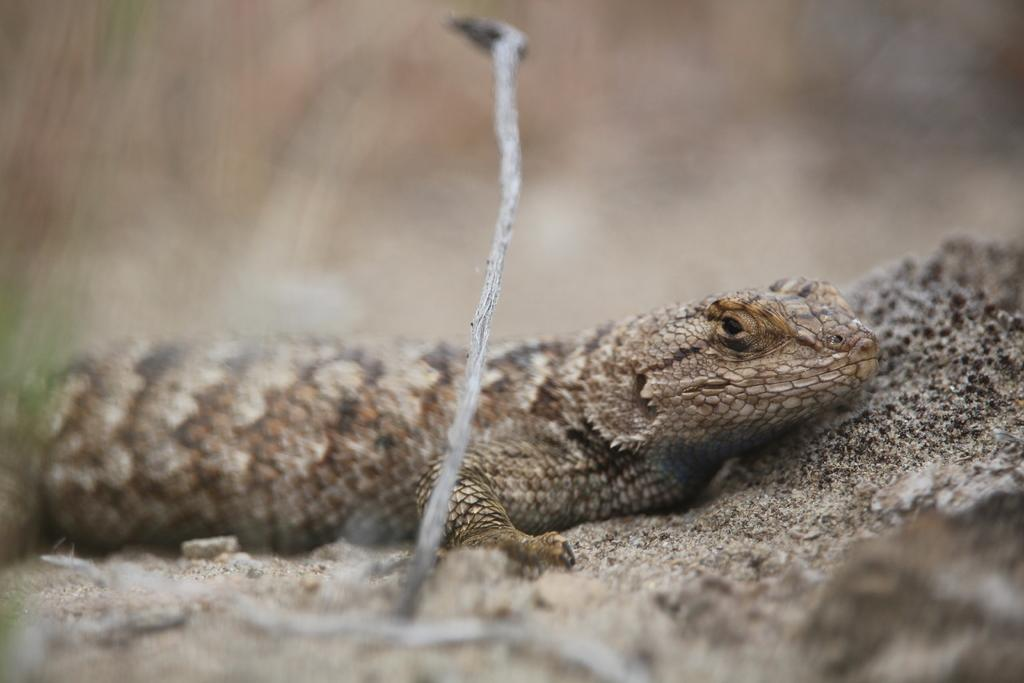What type of animal is in the image? There is a reptile in the image. What can be seen in the foreground of the image? There is a twig in the foreground of the image. How would you describe the background of the image? The background of the image is blurred. What type of furniture is visible in the image? There is no furniture present in the image. Can you see any chalk in the image? There is no chalk present in the image. 